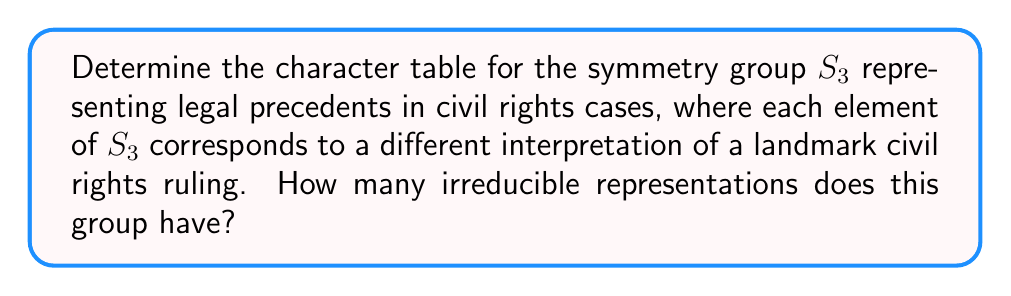Solve this math problem. Let's approach this step-by-step:

1) First, we need to identify the elements of $S_3$. $S_3$ is the symmetric group on 3 elements, which has 6 elements:
   $e$ (identity), $(12)$, $(13)$, $(23)$, $(123)$, $(132)$

2) Next, we determine the conjugacy classes:
   $\{e\}$, $\{(12), (13), (23)\}$, $\{(123), (132)\}$

3) The number of conjugacy classes equals the number of irreducible representations. Here, we have 3 conjugacy classes, so there are 3 irreducible representations.

4) We know that $S_3$ has three irreducible representations:
   - The trivial representation (1-dimensional)
   - The sign representation (1-dimensional)
   - A 2-dimensional representation

5) Now, let's construct the character table:

   $$\begin{array}{c|ccc}
      S_3 & \{e\} & \{(12),(13),(23)\} & \{(123),(132)\} \\
      \hline
      \chi_1 & 1 & 1 & 1 \\
      \chi_2 & 1 & -1 & 1 \\
      \chi_3 & 2 & 0 & -1
   \end{array}$$

6) Interpretation in the context of civil rights cases:
   - $\chi_1$ represents consistent interpretation across all rulings
   - $\chi_2$ represents a change in interpretation for transpositions (swapping two elements)
   - $\chi_3$ represents a more complex interpretation that changes differently for 2-cycles and 3-cycles

This character table provides a mathematical representation of how different legal interpretations of civil rights rulings can be categorized and related to each other, which could be useful in analyzing patterns in judicial decision-making.
Answer: 3 irreducible representations 